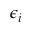Convert formula to latex. <formula><loc_0><loc_0><loc_500><loc_500>\epsilon _ { i }</formula> 